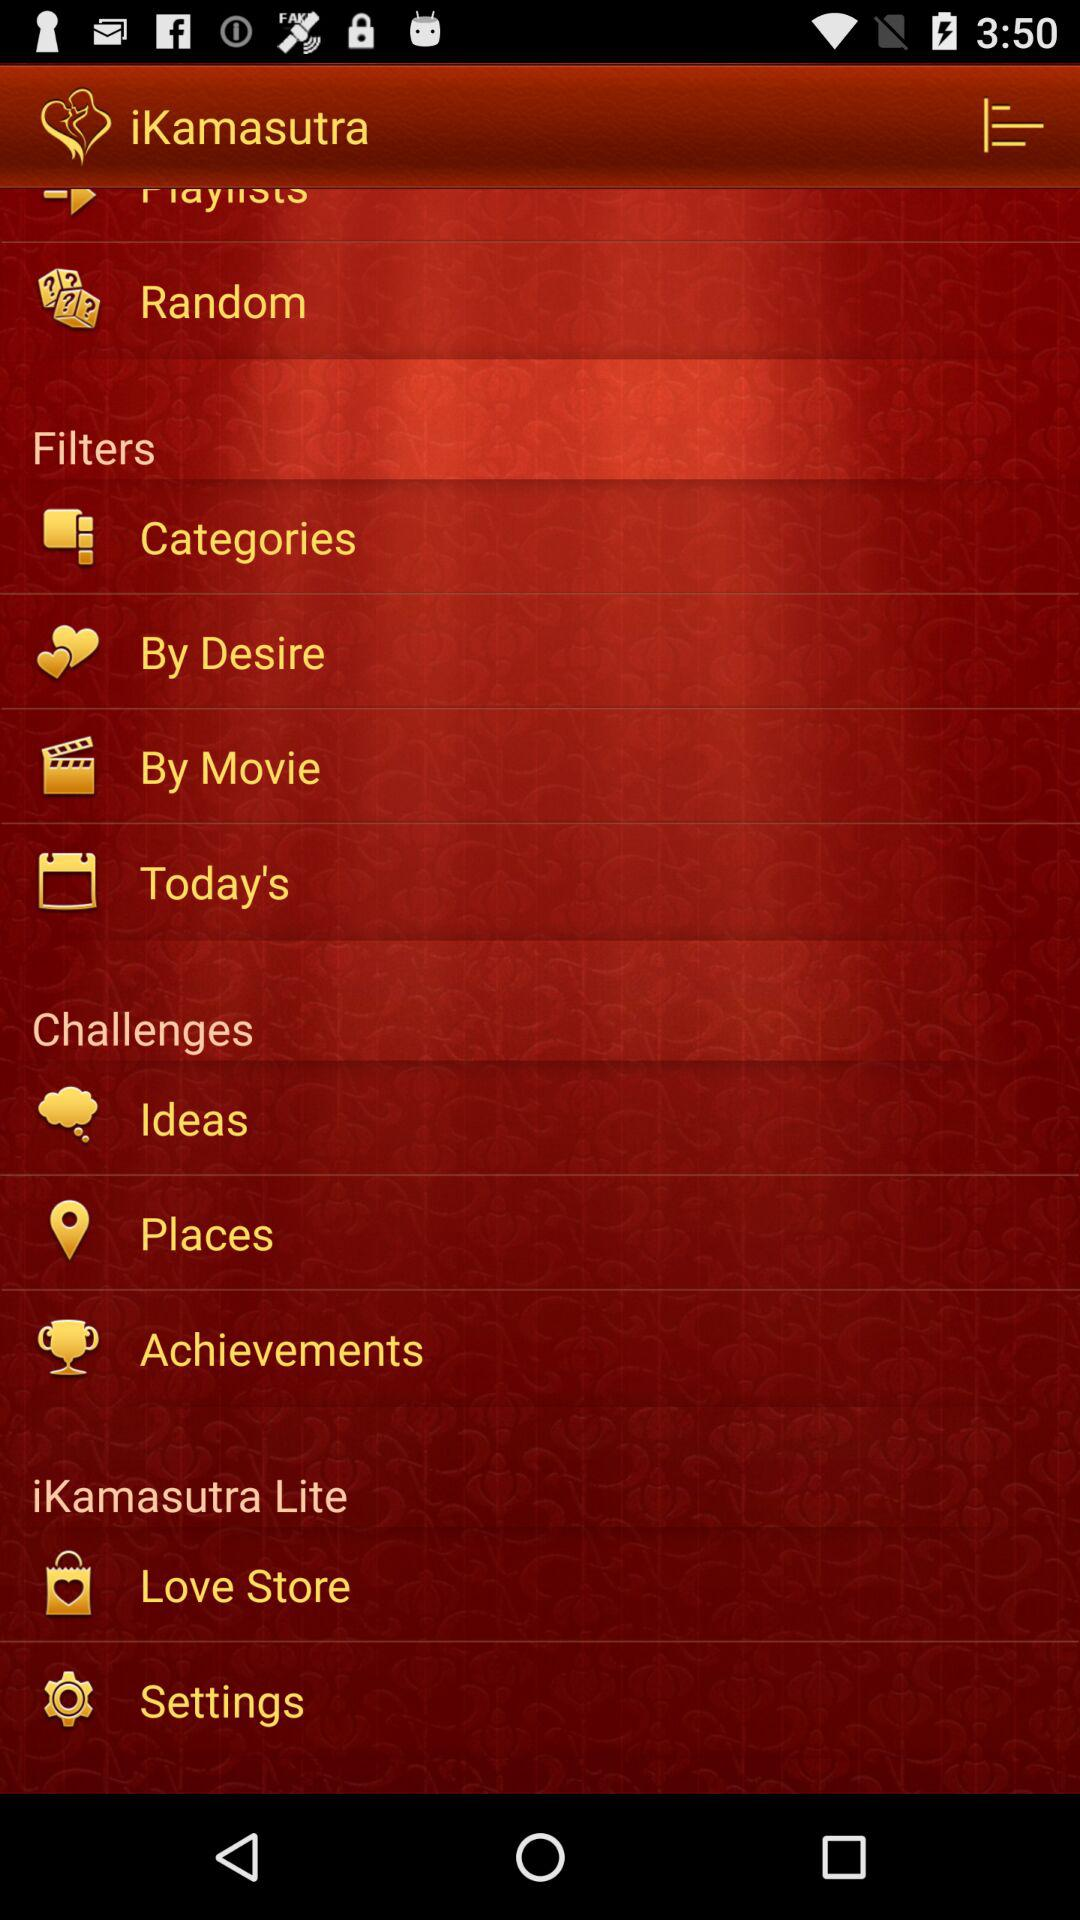How many seconds have passed since the position was unlocked?
Answer the question using a single word or phrase. 3 